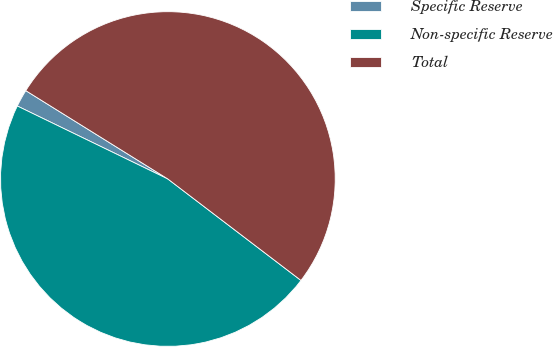<chart> <loc_0><loc_0><loc_500><loc_500><pie_chart><fcel>Specific Reserve<fcel>Non-specific Reserve<fcel>Total<nl><fcel>1.67%<fcel>46.82%<fcel>51.51%<nl></chart> 